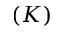<formula> <loc_0><loc_0><loc_500><loc_500>( K )</formula> 